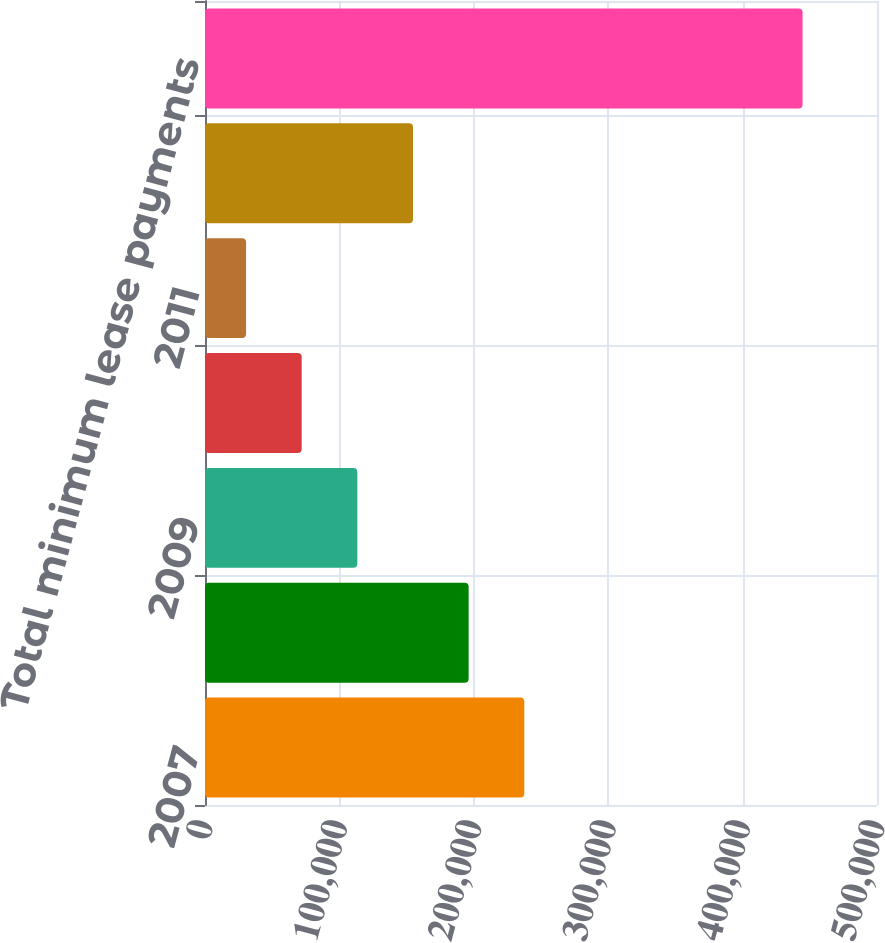Convert chart. <chart><loc_0><loc_0><loc_500><loc_500><bar_chart><fcel>2007<fcel>2008<fcel>2009<fcel>2010<fcel>2011<fcel>Thereafter<fcel>Total minimum lease payments<nl><fcel>237570<fcel>196163<fcel>113349<fcel>71942.1<fcel>30535<fcel>154756<fcel>444606<nl></chart> 